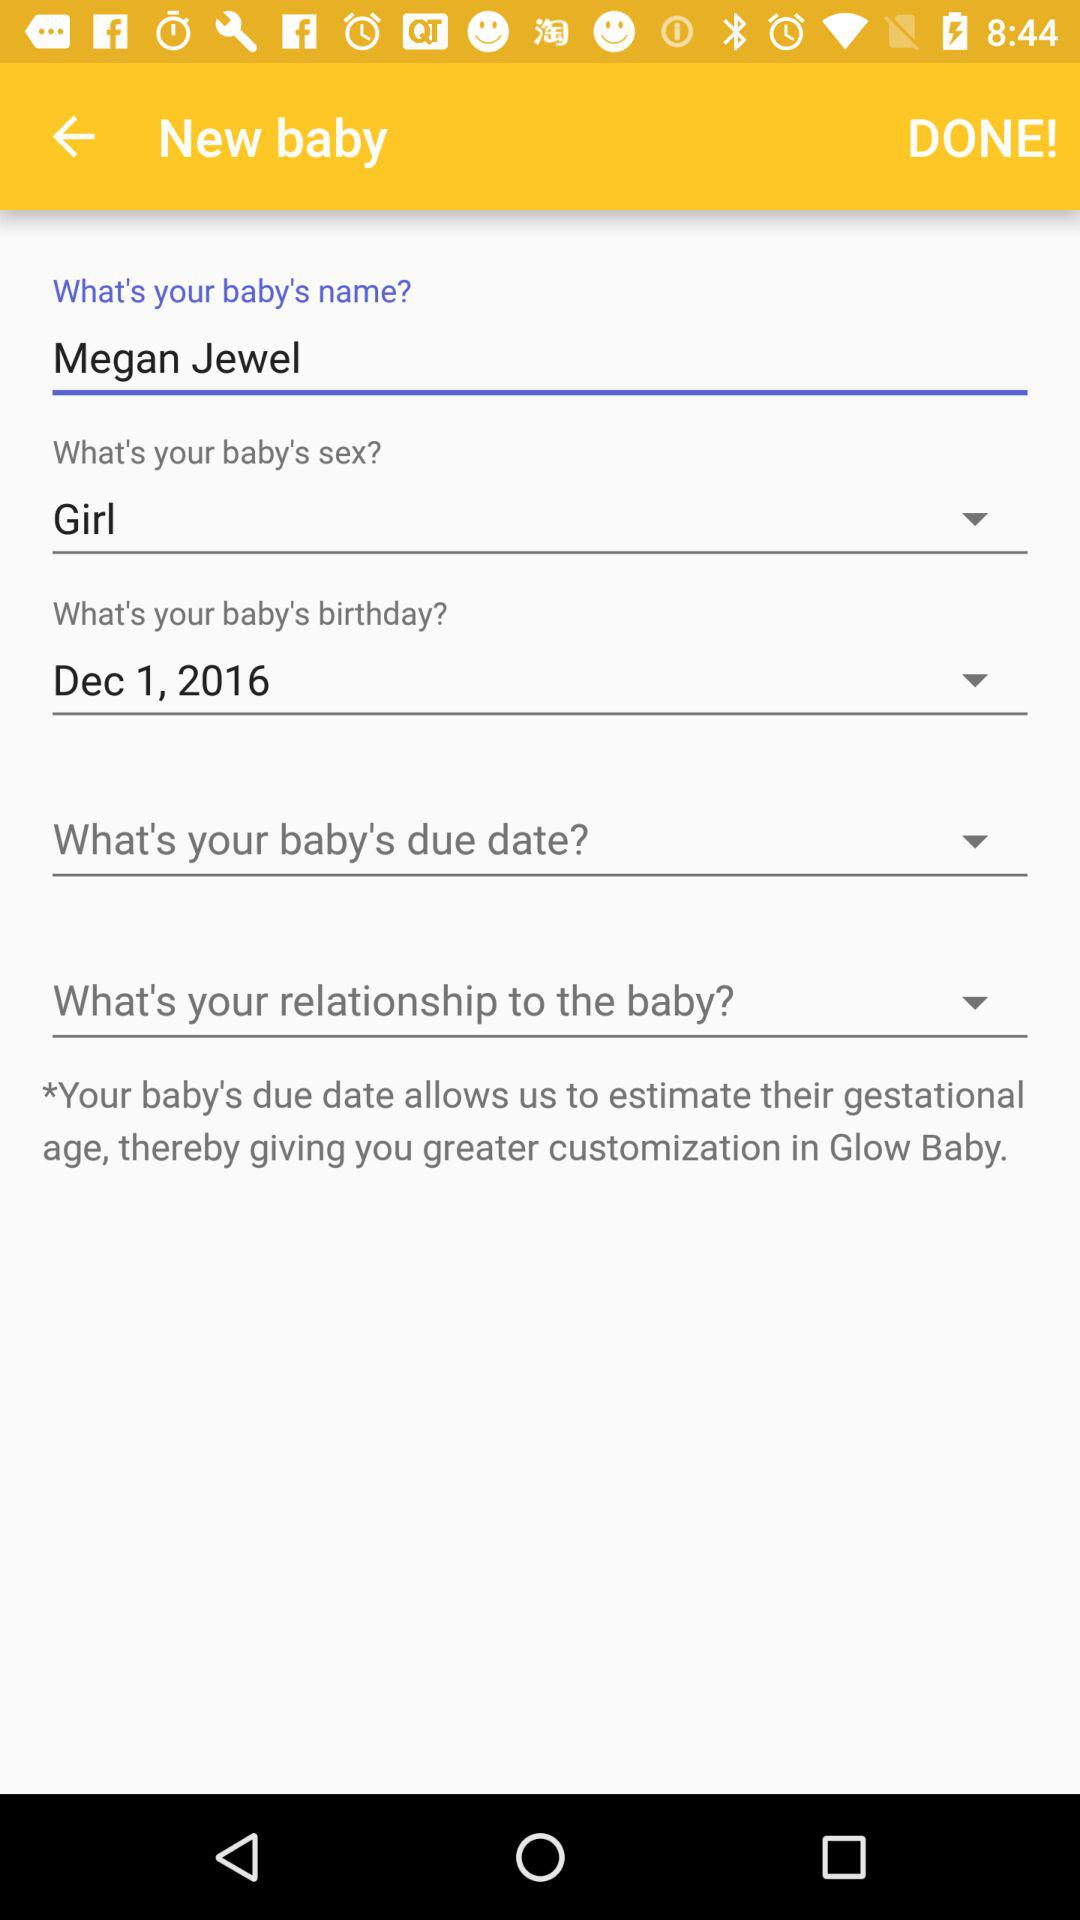What is the baby's birthdate? The baby's birthdate is December 1, 2016. 